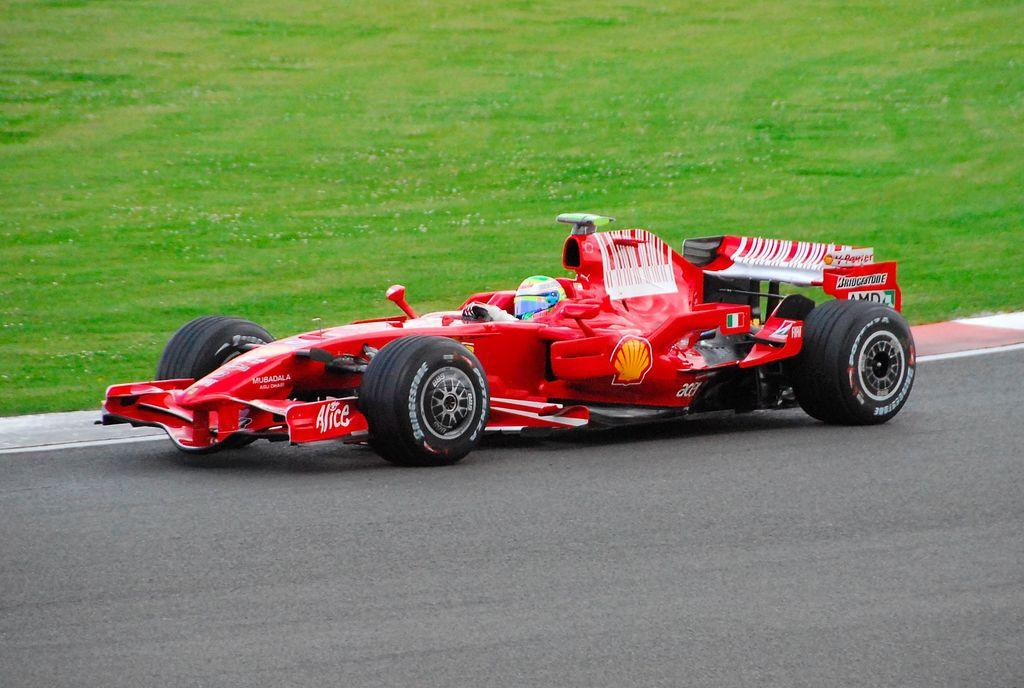What type of vehicle is in the picture? There is a red sports car in the picture. Where is the sports car located? The sports car is on the road. What can be seen on the ground in the picture? There is grass visible on the ground. What type of ray is swimming in the grass in the image? There is no ray or water present in the image; it features a red sports car on the road with grass visible on the ground. 